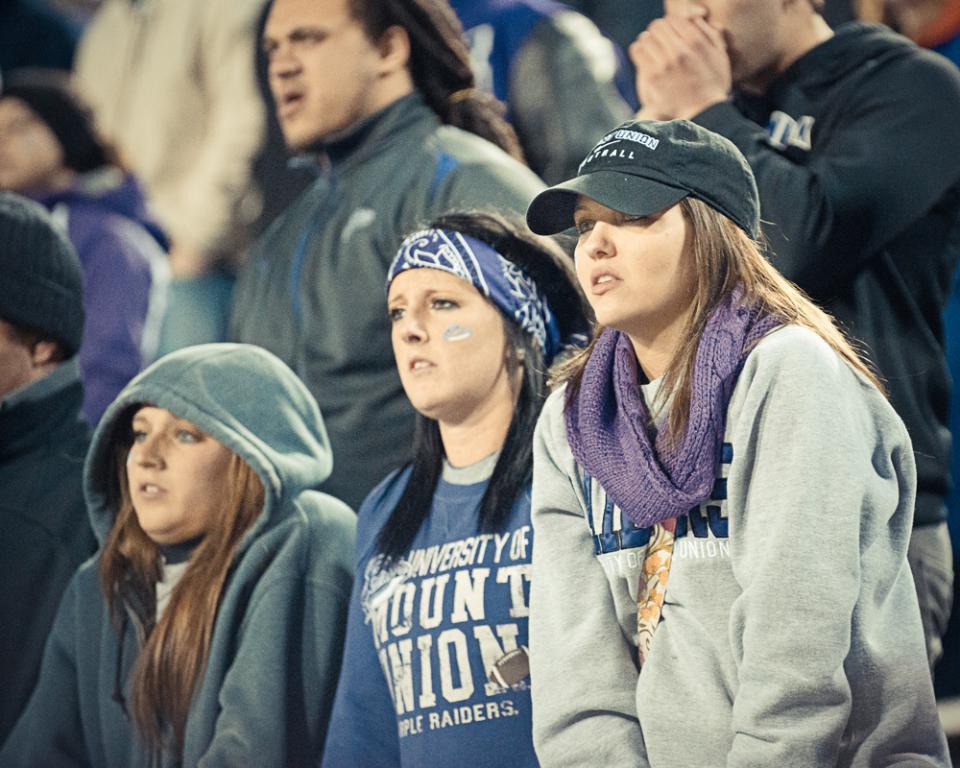Describe this image in one or two sentences. There are persons in different color dresses standing. And the background is blurred. 